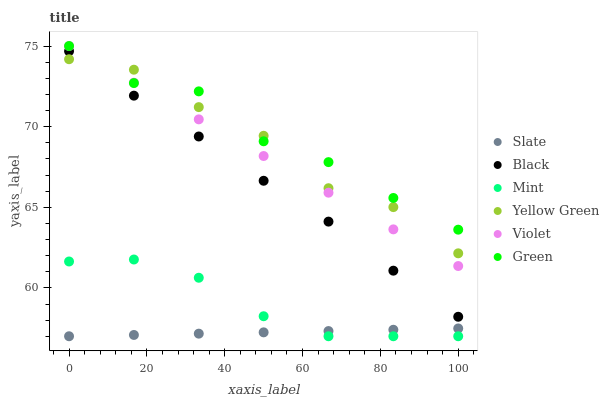Does Slate have the minimum area under the curve?
Answer yes or no. Yes. Does Green have the maximum area under the curve?
Answer yes or no. Yes. Does Green have the minimum area under the curve?
Answer yes or no. No. Does Slate have the maximum area under the curve?
Answer yes or no. No. Is Slate the smoothest?
Answer yes or no. Yes. Is Yellow Green the roughest?
Answer yes or no. Yes. Is Green the smoothest?
Answer yes or no. No. Is Green the roughest?
Answer yes or no. No. Does Slate have the lowest value?
Answer yes or no. Yes. Does Green have the lowest value?
Answer yes or no. No. Does Violet have the highest value?
Answer yes or no. Yes. Does Slate have the highest value?
Answer yes or no. No. Is Black less than Green?
Answer yes or no. Yes. Is Black greater than Slate?
Answer yes or no. Yes. Does Green intersect Yellow Green?
Answer yes or no. Yes. Is Green less than Yellow Green?
Answer yes or no. No. Is Green greater than Yellow Green?
Answer yes or no. No. Does Black intersect Green?
Answer yes or no. No. 